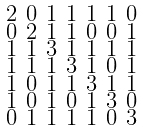<formula> <loc_0><loc_0><loc_500><loc_500>\begin{smallmatrix} 2 & 0 & 1 & 1 & 1 & 1 & 0 \\ 0 & 2 & 1 & 1 & 0 & 0 & 1 \\ 1 & 1 & 3 & 1 & 1 & 1 & 1 \\ 1 & 1 & 1 & 3 & 1 & 0 & 1 \\ 1 & 0 & 1 & 1 & 3 & 1 & 1 \\ 1 & 0 & 1 & 0 & 1 & 3 & 0 \\ 0 & 1 & 1 & 1 & 1 & 0 & 3 \end{smallmatrix}</formula> 